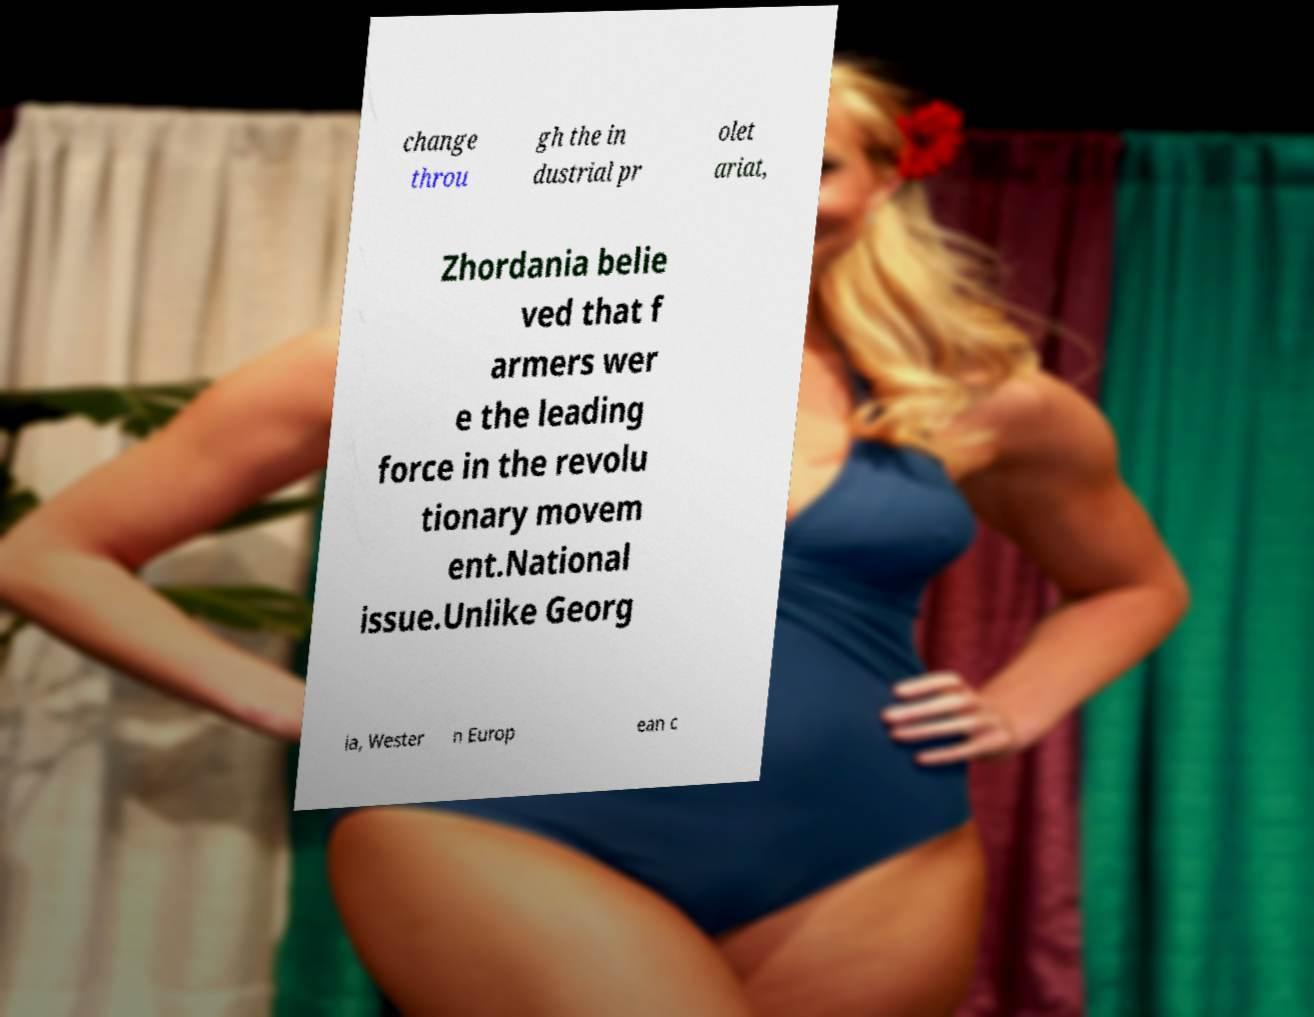I need the written content from this picture converted into text. Can you do that? change throu gh the in dustrial pr olet ariat, Zhordania belie ved that f armers wer e the leading force in the revolu tionary movem ent.National issue.Unlike Georg ia, Wester n Europ ean c 